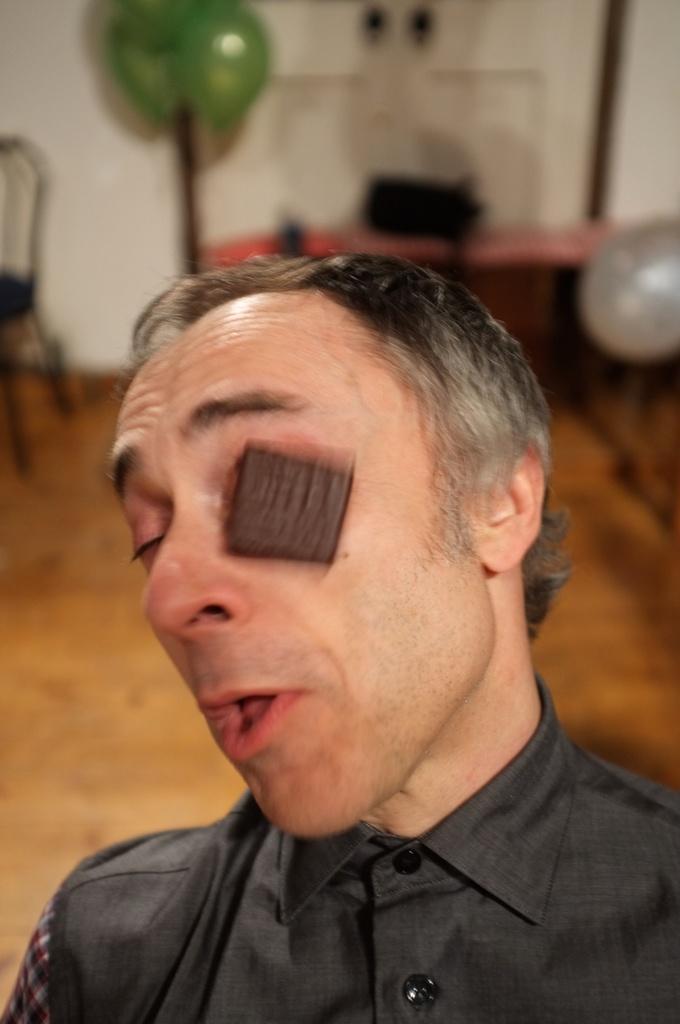Could you give a brief overview of what you see in this image? As we can see in the image in the front there is a man. In the background there is a table, chair, balloons and a white color wall. 